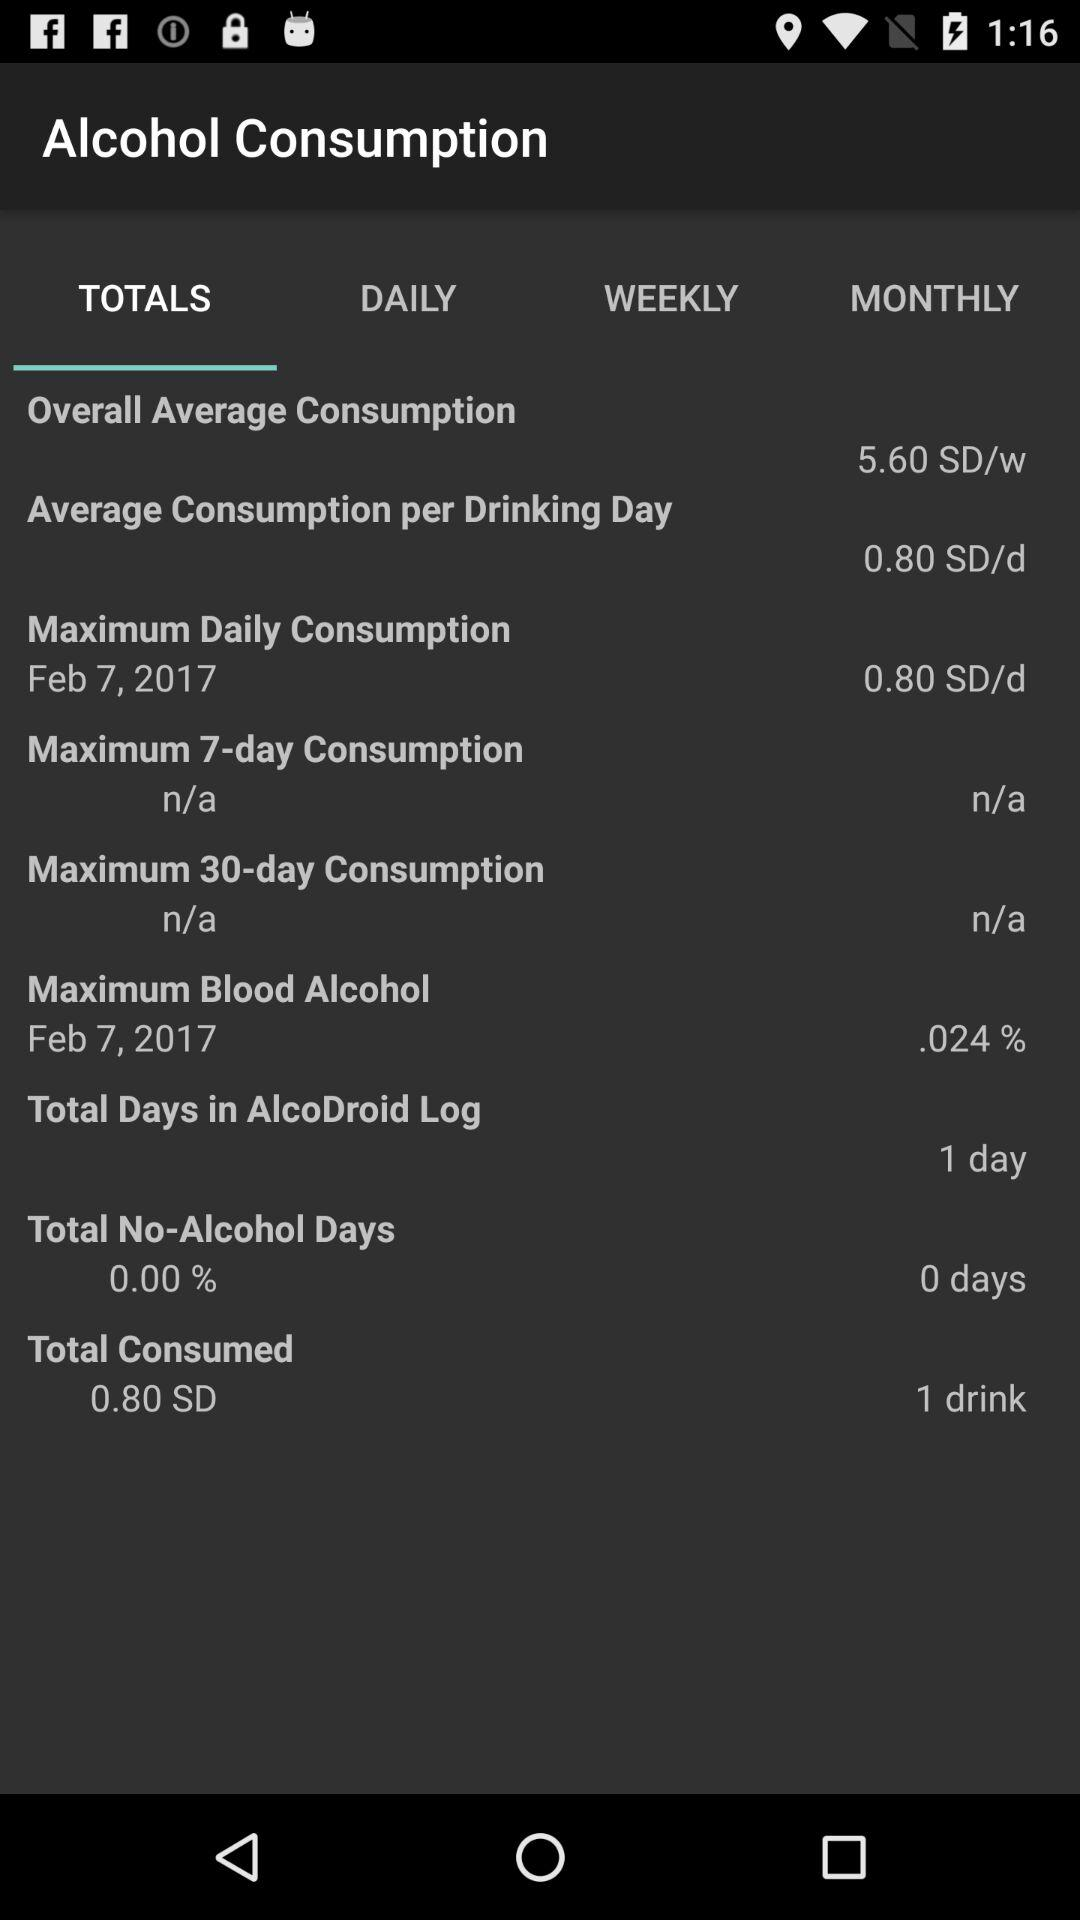What is the total number of no-alcohol days? The total number of no-alcohol days is 0. 